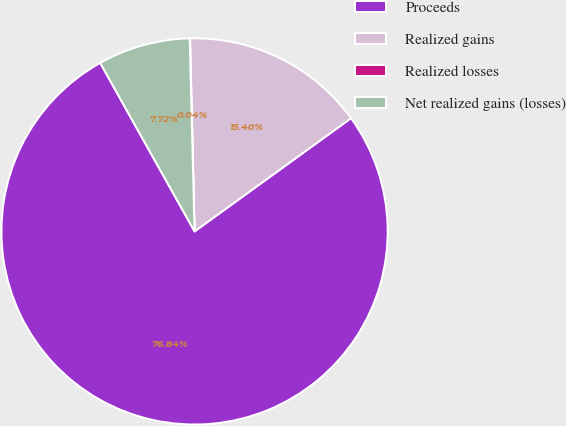<chart> <loc_0><loc_0><loc_500><loc_500><pie_chart><fcel>Proceeds<fcel>Realized gains<fcel>Realized losses<fcel>Net realized gains (losses)<nl><fcel>76.85%<fcel>15.4%<fcel>0.04%<fcel>7.72%<nl></chart> 